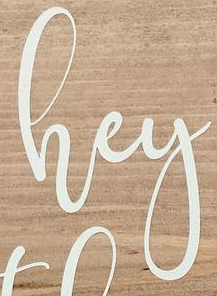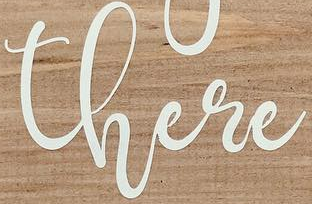Read the text from these images in sequence, separated by a semicolon. hey; there 